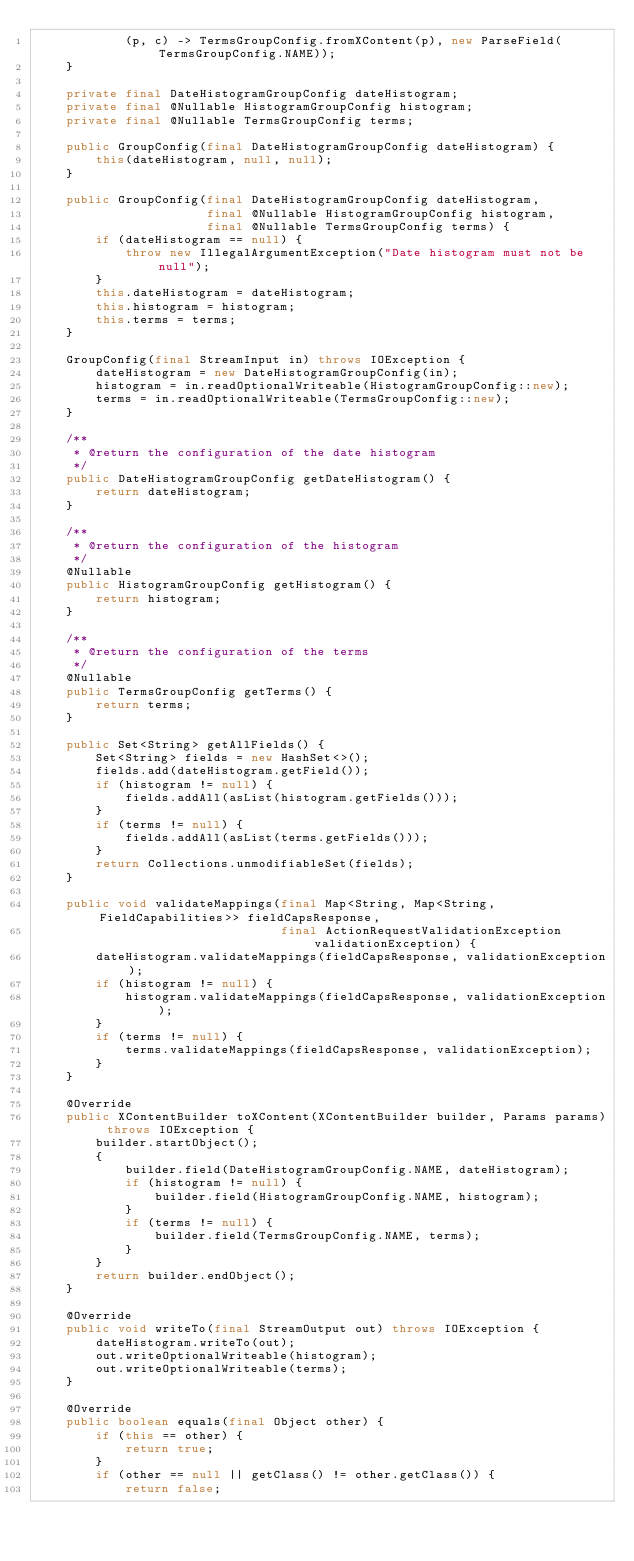<code> <loc_0><loc_0><loc_500><loc_500><_Java_>            (p, c) -> TermsGroupConfig.fromXContent(p), new ParseField(TermsGroupConfig.NAME));
    }

    private final DateHistogramGroupConfig dateHistogram;
    private final @Nullable HistogramGroupConfig histogram;
    private final @Nullable TermsGroupConfig terms;

    public GroupConfig(final DateHistogramGroupConfig dateHistogram) {
        this(dateHistogram, null, null);
    }

    public GroupConfig(final DateHistogramGroupConfig dateHistogram,
                       final @Nullable HistogramGroupConfig histogram,
                       final @Nullable TermsGroupConfig terms) {
        if (dateHistogram == null) {
            throw new IllegalArgumentException("Date histogram must not be null");
        }
        this.dateHistogram = dateHistogram;
        this.histogram = histogram;
        this.terms = terms;
    }

    GroupConfig(final StreamInput in) throws IOException {
        dateHistogram = new DateHistogramGroupConfig(in);
        histogram = in.readOptionalWriteable(HistogramGroupConfig::new);
        terms = in.readOptionalWriteable(TermsGroupConfig::new);
    }

    /**
     * @return the configuration of the date histogram
     */
    public DateHistogramGroupConfig getDateHistogram() {
        return dateHistogram;
    }

    /**
     * @return the configuration of the histogram
     */
    @Nullable
    public HistogramGroupConfig getHistogram() {
        return histogram;
    }

    /**
     * @return the configuration of the terms
     */
    @Nullable
    public TermsGroupConfig getTerms() {
        return terms;
    }

    public Set<String> getAllFields() {
        Set<String> fields = new HashSet<>();
        fields.add(dateHistogram.getField());
        if (histogram != null) {
            fields.addAll(asList(histogram.getFields()));
        }
        if (terms != null) {
            fields.addAll(asList(terms.getFields()));
        }
        return Collections.unmodifiableSet(fields);
    }

    public void validateMappings(final Map<String, Map<String, FieldCapabilities>> fieldCapsResponse,
                                 final ActionRequestValidationException validationException) {
        dateHistogram.validateMappings(fieldCapsResponse, validationException);
        if (histogram != null) {
            histogram.validateMappings(fieldCapsResponse, validationException);
        }
        if (terms != null) {
            terms.validateMappings(fieldCapsResponse, validationException);
        }
    }

    @Override
    public XContentBuilder toXContent(XContentBuilder builder, Params params) throws IOException {
        builder.startObject();
        {
            builder.field(DateHistogramGroupConfig.NAME, dateHistogram);
            if (histogram != null) {
                builder.field(HistogramGroupConfig.NAME, histogram);
            }
            if (terms != null) {
                builder.field(TermsGroupConfig.NAME, terms);
            }
        }
        return builder.endObject();
    }

    @Override
    public void writeTo(final StreamOutput out) throws IOException {
        dateHistogram.writeTo(out);
        out.writeOptionalWriteable(histogram);
        out.writeOptionalWriteable(terms);
    }

    @Override
    public boolean equals(final Object other) {
        if (this == other) {
            return true;
        }
        if (other == null || getClass() != other.getClass()) {
            return false;</code> 